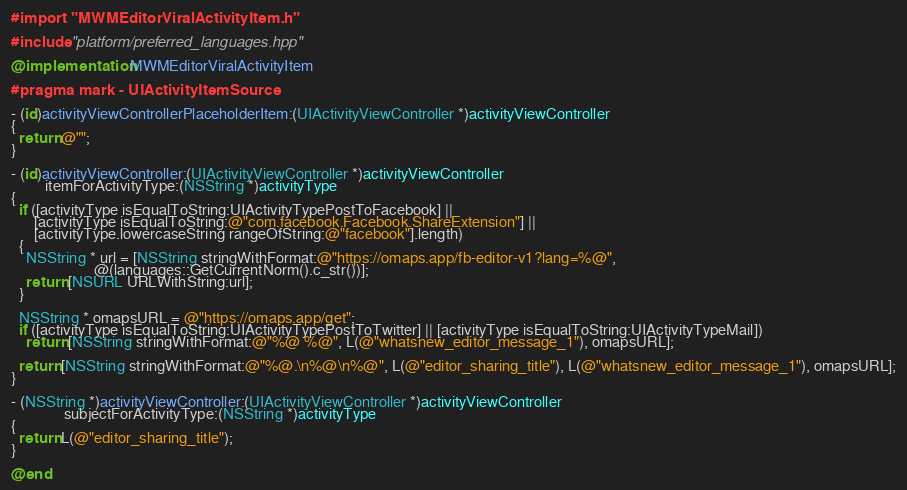Convert code to text. <code><loc_0><loc_0><loc_500><loc_500><_ObjectiveC_>#import "MWMEditorViralActivityItem.h"

#include "platform/preferred_languages.hpp"

@implementation MWMEditorViralActivityItem

#pragma mark - UIActivityItemSource

- (id)activityViewControllerPlaceholderItem:(UIActivityViewController *)activityViewController
{
  return @"";
}

- (id)activityViewController:(UIActivityViewController *)activityViewController
         itemForActivityType:(NSString *)activityType
{
  if ([activityType isEqualToString:UIActivityTypePostToFacebook] ||
      [activityType isEqualToString:@"com.facebook.Facebook.ShareExtension"] ||
      [activityType.lowercaseString rangeOfString:@"facebook"].length)
  {
    NSString * url = [NSString stringWithFormat:@"https://omaps.app/fb-editor-v1?lang=%@",
                      @(languages::GetCurrentNorm().c_str())];
    return [NSURL URLWithString:url];
  }

  NSString * omapsURL = @"https://omaps.app/get";
  if ([activityType isEqualToString:UIActivityTypePostToTwitter] || [activityType isEqualToString:UIActivityTypeMail])
    return [NSString stringWithFormat:@"%@ %@", L(@"whatsnew_editor_message_1"), omapsURL];

  return [NSString stringWithFormat:@"%@.\n%@\n%@", L(@"editor_sharing_title"), L(@"whatsnew_editor_message_1"), omapsURL];
}

- (NSString *)activityViewController:(UIActivityViewController *)activityViewController
              subjectForActivityType:(NSString *)activityType
{
  return L(@"editor_sharing_title");
}

@end
</code> 